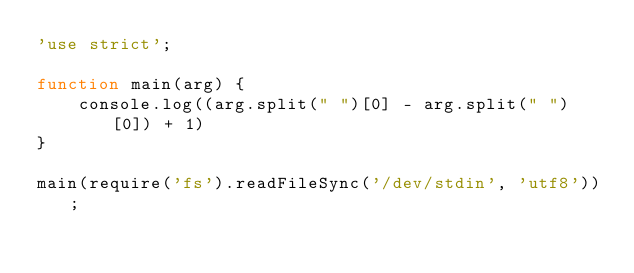Convert code to text. <code><loc_0><loc_0><loc_500><loc_500><_JavaScript_>'use strict';

function main(arg) {
    console.log((arg.split(" ")[0] - arg.split(" ")[0]) + 1)
}

main(require('fs').readFileSync('/dev/stdin', 'utf8'));</code> 